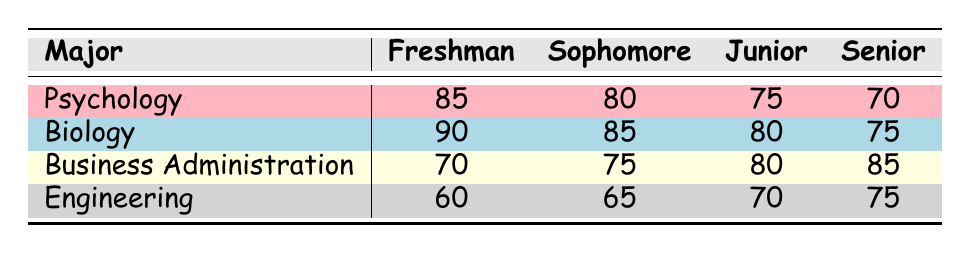What is the engagement level of Psychology students in their Junior year? From the table, the engagement level for Psychology in the Junior year is listed directly under that category. It shows a value of 75.
Answer: 75 What is the trend in engagement levels for Biology students from Freshman to Senior year? By examining the table, we can see that the engagement levels for Biology students decrease from 90 in Freshman to 75 in Senior year, indicating a downward trend.
Answer: Downward trend Which major has the highest engagement level in the Senior year? In the Senior year column, we can observe the engagement levels: Psychology (70), Biology (75), Business Administration (85), and Engineering (75). Business Administration has the highest level at 85.
Answer: Business Administration What is the average engagement level for Business Administration students? The engagement levels for Business Administration across years are 70, 75, 80, and 85. We add these values (70 + 75 + 80 + 85 = 310) and divide by the number of years (4) to get the average: 310/4 = 77.5.
Answer: 77.5 Is it true that Senior Engineering students have a higher engagement level than Junior Psychology students? The engagement level for Senior Engineering students is 75, while for Junior Psychology students, it is 75 as well. Since both values are equal, the statement is not true.
Answer: No Which major experiences the least engagement in their Freshman year? Looking at the Freshman row, we see the following engagement levels: Psychology (85), Biology (90), Business Administration (70), and Engineering (60). Engineering has the lowest engagement level at 60.
Answer: Engineering What is the difference in engagement levels between Sophomore Psychology and Sophomore Business Administration students? We can find the engagement levels: Psychology Sophomore is 80 and Business Administration Sophomore is 75. The difference is calculated as 80 - 75 = 5.
Answer: 5 Which major shows the most significant decrease in engagement from Freshman to Senior year? We calculate the decrease for each major: Psychology (85 to 70, a drop of 15), Biology (90 to 75, a drop of 15), Business Administration (70 to 85, an increase of 15), and Engineering (60 to 75, an increase of 15). Psychology and Biology both have the largest decrease of 15.
Answer: Psychology and Biology 